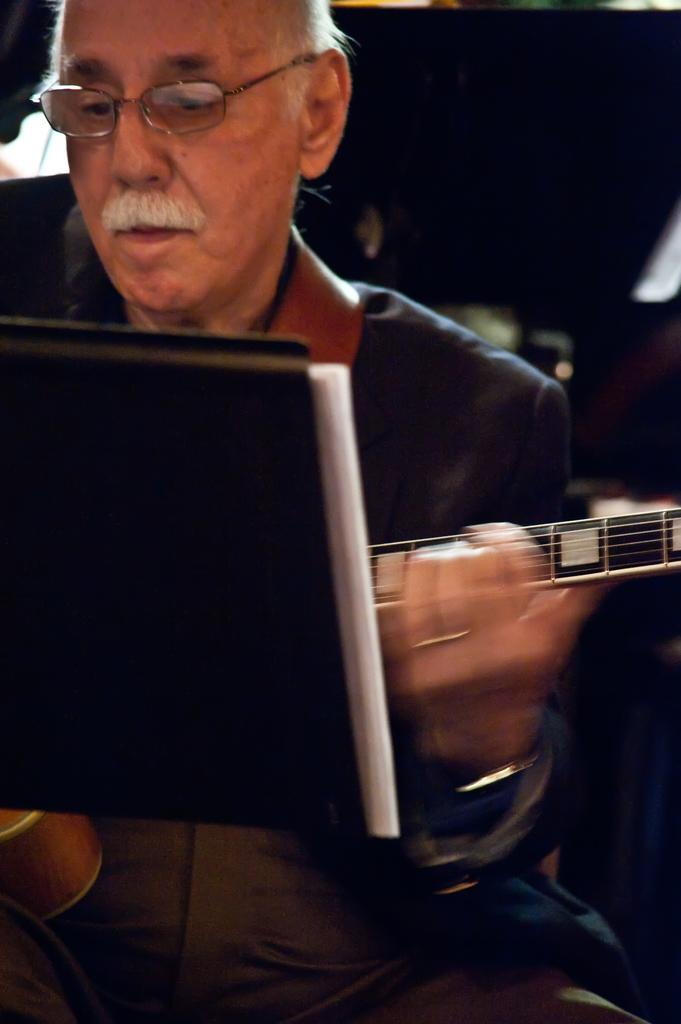Who is present in the image? There is a man in the image. What is the man holding in the image? The man is holding a guitar. What object is in front of the man? There is a book in front of the man. What color is the orange the man is holding in the image? There is no orange present in the image; the man is holding a guitar. 